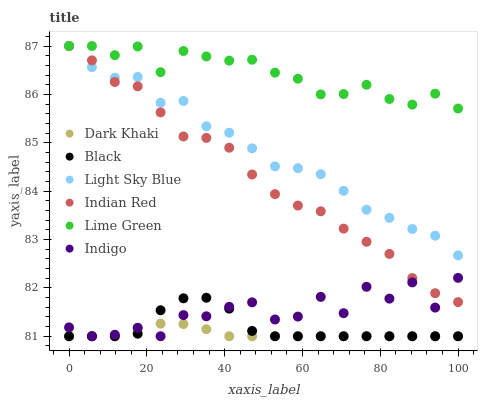Does Dark Khaki have the minimum area under the curve?
Answer yes or no. Yes. Does Lime Green have the maximum area under the curve?
Answer yes or no. Yes. Does Light Sky Blue have the minimum area under the curve?
Answer yes or no. No. Does Light Sky Blue have the maximum area under the curve?
Answer yes or no. No. Is Dark Khaki the smoothest?
Answer yes or no. Yes. Is Indigo the roughest?
Answer yes or no. Yes. Is Light Sky Blue the smoothest?
Answer yes or no. No. Is Light Sky Blue the roughest?
Answer yes or no. No. Does Indigo have the lowest value?
Answer yes or no. Yes. Does Light Sky Blue have the lowest value?
Answer yes or no. No. Does Lime Green have the highest value?
Answer yes or no. Yes. Does Dark Khaki have the highest value?
Answer yes or no. No. Is Indigo less than Lime Green?
Answer yes or no. Yes. Is Lime Green greater than Dark Khaki?
Answer yes or no. Yes. Does Dark Khaki intersect Indigo?
Answer yes or no. Yes. Is Dark Khaki less than Indigo?
Answer yes or no. No. Is Dark Khaki greater than Indigo?
Answer yes or no. No. Does Indigo intersect Lime Green?
Answer yes or no. No. 